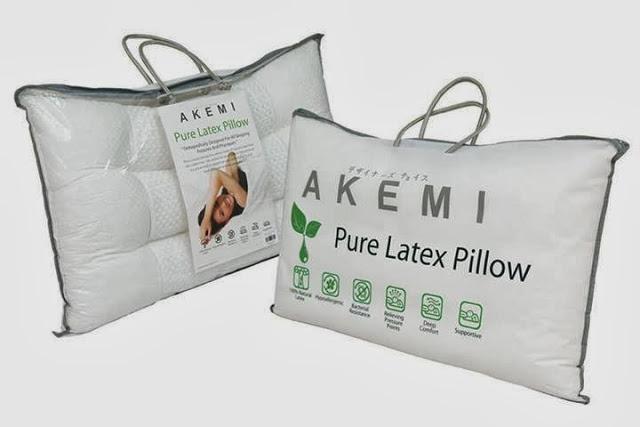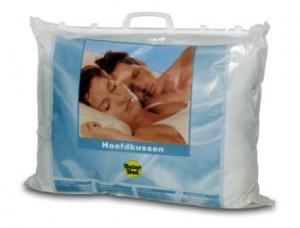The first image is the image on the left, the second image is the image on the right. For the images shown, is this caption "We see one pillow in the image on the right." true? Answer yes or no. Yes. 